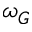<formula> <loc_0><loc_0><loc_500><loc_500>\omega _ { G }</formula> 